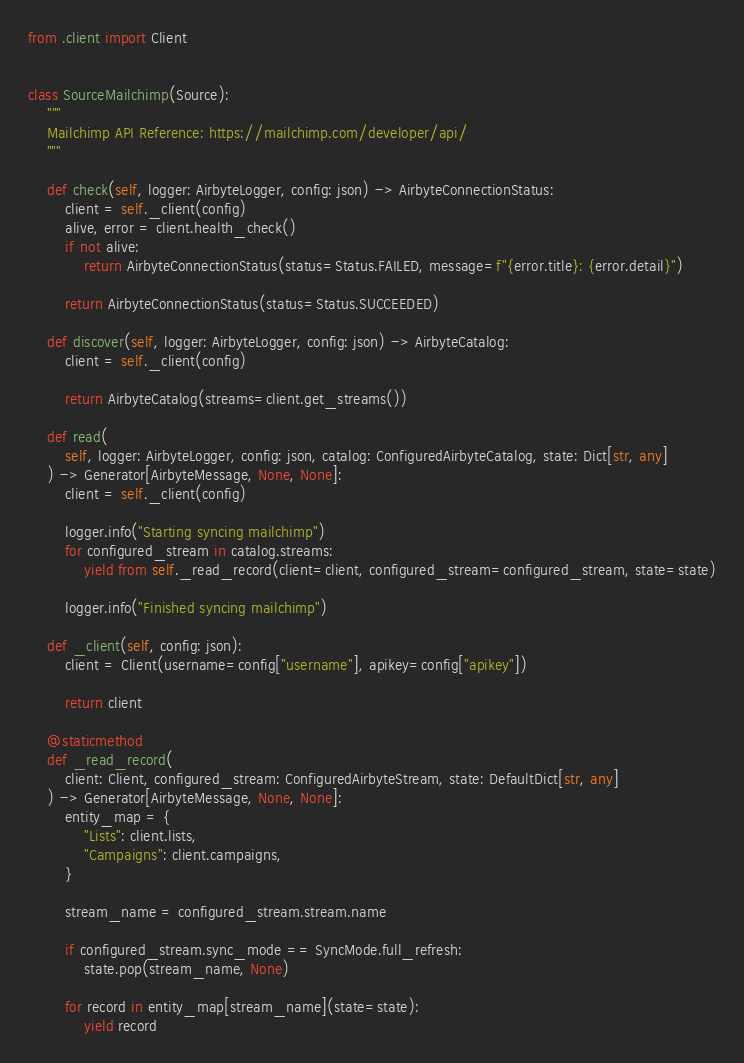Convert code to text. <code><loc_0><loc_0><loc_500><loc_500><_Python_>from .client import Client


class SourceMailchimp(Source):
    """
    Mailchimp API Reference: https://mailchimp.com/developer/api/
    """

    def check(self, logger: AirbyteLogger, config: json) -> AirbyteConnectionStatus:
        client = self._client(config)
        alive, error = client.health_check()
        if not alive:
            return AirbyteConnectionStatus(status=Status.FAILED, message=f"{error.title}: {error.detail}")

        return AirbyteConnectionStatus(status=Status.SUCCEEDED)

    def discover(self, logger: AirbyteLogger, config: json) -> AirbyteCatalog:
        client = self._client(config)

        return AirbyteCatalog(streams=client.get_streams())

    def read(
        self, logger: AirbyteLogger, config: json, catalog: ConfiguredAirbyteCatalog, state: Dict[str, any]
    ) -> Generator[AirbyteMessage, None, None]:
        client = self._client(config)

        logger.info("Starting syncing mailchimp")
        for configured_stream in catalog.streams:
            yield from self._read_record(client=client, configured_stream=configured_stream, state=state)

        logger.info("Finished syncing mailchimp")

    def _client(self, config: json):
        client = Client(username=config["username"], apikey=config["apikey"])

        return client

    @staticmethod
    def _read_record(
        client: Client, configured_stream: ConfiguredAirbyteStream, state: DefaultDict[str, any]
    ) -> Generator[AirbyteMessage, None, None]:
        entity_map = {
            "Lists": client.lists,
            "Campaigns": client.campaigns,
        }

        stream_name = configured_stream.stream.name

        if configured_stream.sync_mode == SyncMode.full_refresh:
            state.pop(stream_name, None)

        for record in entity_map[stream_name](state=state):
            yield record
</code> 